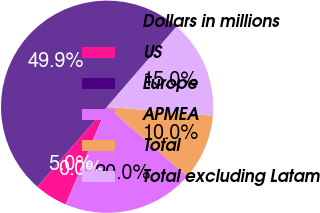Convert chart to OTSL. <chart><loc_0><loc_0><loc_500><loc_500><pie_chart><fcel>Dollars in millions<fcel>US<fcel>Europe<fcel>APMEA<fcel>Total<fcel>Total excluding Latam<nl><fcel>49.95%<fcel>5.02%<fcel>0.02%<fcel>20.0%<fcel>10.01%<fcel>15.0%<nl></chart> 